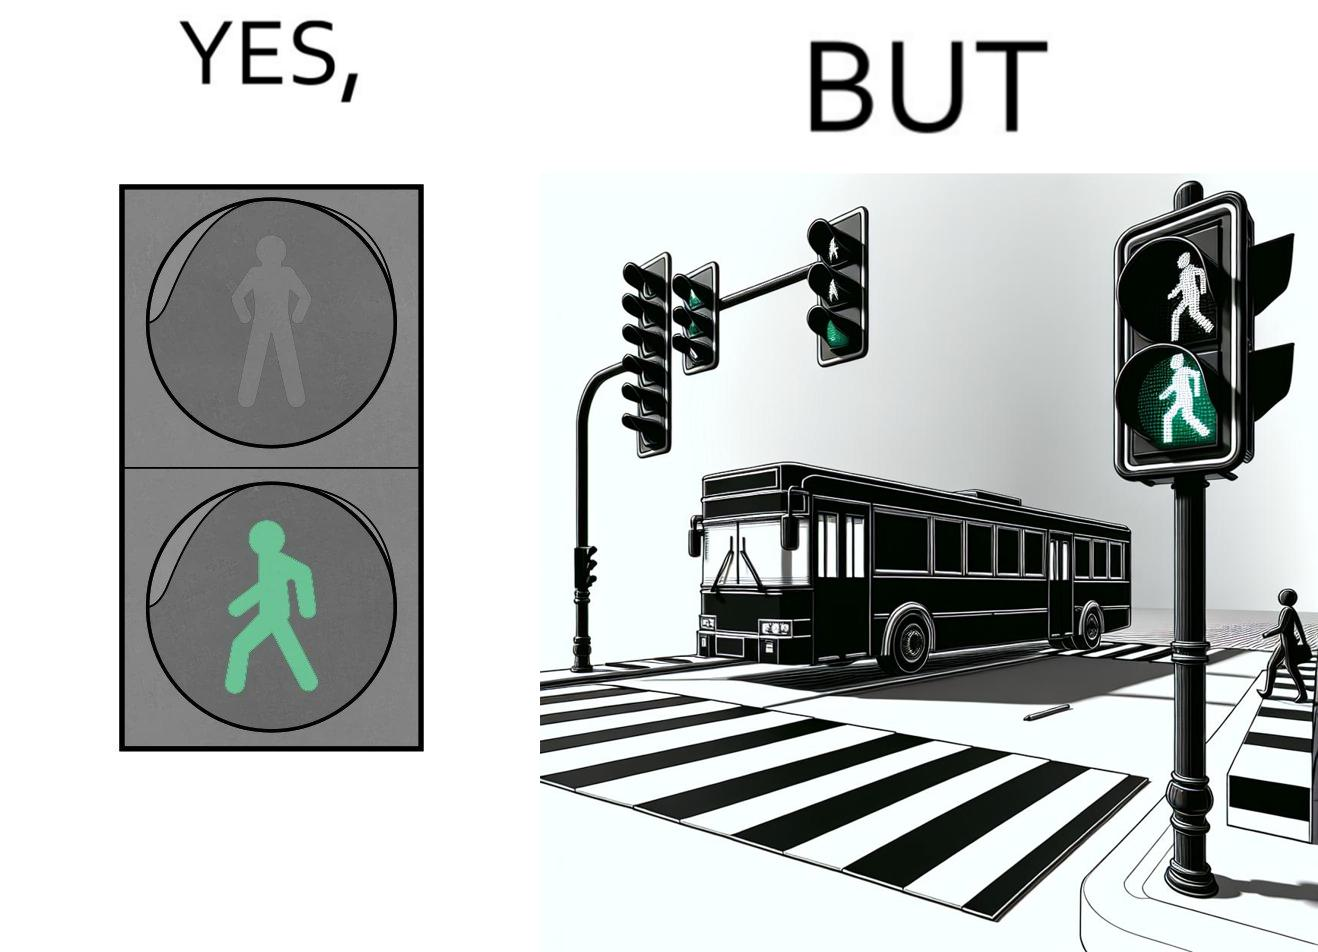Does this image contain satire or humor? Yes, this image is satirical. 